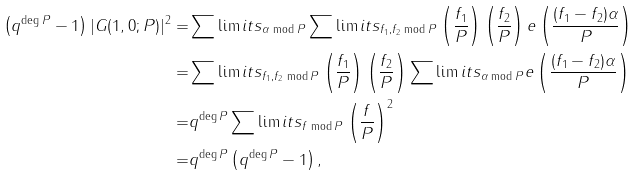<formula> <loc_0><loc_0><loc_500><loc_500>\left ( q ^ { \deg P } - 1 \right ) | G ( 1 , 0 ; P ) | ^ { 2 } = & \sum \lim i t s _ { \alpha \bmod { P } } \sum \lim i t s _ { f _ { 1 } , f _ { 2 } \bmod P } \left ( \frac { f _ { 1 } } { P } \right ) \left ( \frac { f _ { 2 } } { P } \right ) e \left ( \frac { ( f _ { 1 } - f _ { 2 } ) \alpha } { P } \right ) \\ = & \sum \lim i t s _ { f _ { 1 } , f _ { 2 } \bmod P } \left ( \frac { f _ { 1 } } { P } \right ) \left ( \frac { f _ { 2 } } { P } \right ) \sum \lim i t s _ { \alpha \bmod { P } } e \left ( \frac { ( f _ { 1 } - f _ { 2 } ) \alpha } { P } \right ) \\ = & q ^ { \deg P } \sum \lim i t s _ { f \bmod P } \left ( \frac { f } { P } \right ) ^ { 2 } \\ = & q ^ { \deg P } \left ( q ^ { \deg P } - 1 \right ) ,</formula> 